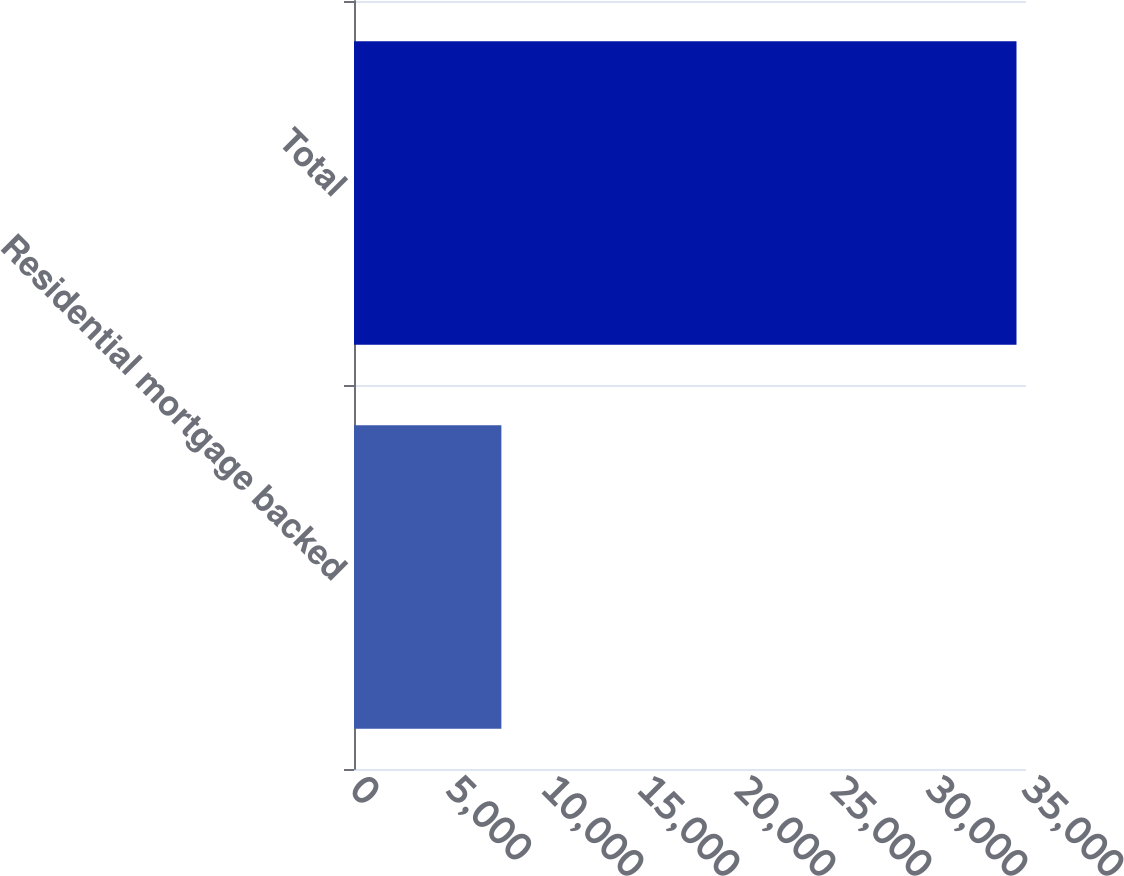Convert chart. <chart><loc_0><loc_0><loc_500><loc_500><bar_chart><fcel>Residential mortgage backed<fcel>Total<nl><fcel>7676<fcel>34505<nl></chart> 